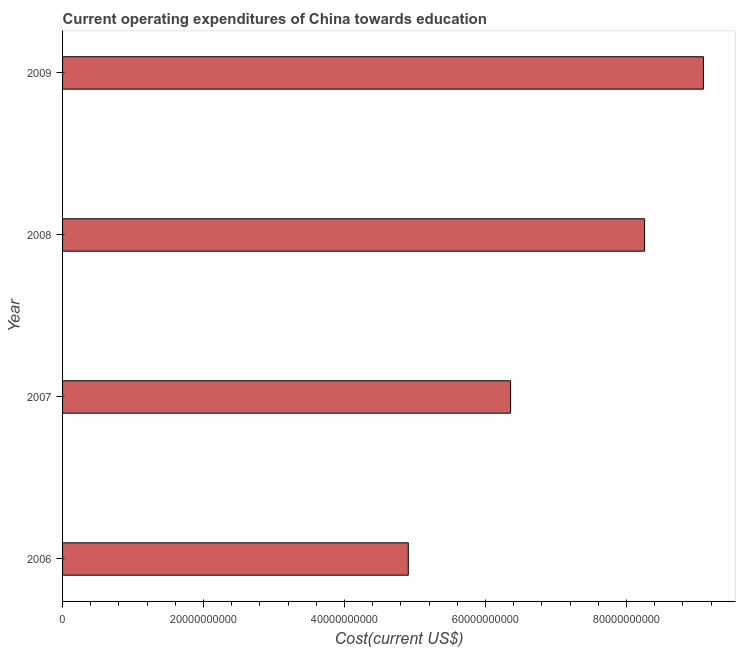Does the graph contain grids?
Ensure brevity in your answer.  No. What is the title of the graph?
Offer a very short reply. Current operating expenditures of China towards education. What is the label or title of the X-axis?
Keep it short and to the point. Cost(current US$). What is the label or title of the Y-axis?
Offer a very short reply. Year. What is the education expenditure in 2009?
Your answer should be compact. 9.09e+1. Across all years, what is the maximum education expenditure?
Make the answer very short. 9.09e+1. Across all years, what is the minimum education expenditure?
Your answer should be very brief. 4.90e+1. In which year was the education expenditure maximum?
Offer a terse response. 2009. What is the sum of the education expenditure?
Keep it short and to the point. 2.86e+11. What is the difference between the education expenditure in 2008 and 2009?
Provide a succinct answer. -8.35e+09. What is the average education expenditure per year?
Your answer should be very brief. 7.15e+1. What is the median education expenditure?
Offer a terse response. 7.31e+1. In how many years, is the education expenditure greater than 60000000000 US$?
Make the answer very short. 3. Do a majority of the years between 2008 and 2009 (inclusive) have education expenditure greater than 40000000000 US$?
Offer a very short reply. Yes. What is the ratio of the education expenditure in 2006 to that in 2009?
Provide a succinct answer. 0.54. What is the difference between the highest and the second highest education expenditure?
Your answer should be very brief. 8.35e+09. What is the difference between the highest and the lowest education expenditure?
Your answer should be compact. 4.19e+1. How many bars are there?
Ensure brevity in your answer.  4. Are all the bars in the graph horizontal?
Make the answer very short. Yes. How many years are there in the graph?
Your answer should be compact. 4. Are the values on the major ticks of X-axis written in scientific E-notation?
Make the answer very short. No. What is the Cost(current US$) in 2006?
Your answer should be very brief. 4.90e+1. What is the Cost(current US$) in 2007?
Provide a succinct answer. 6.36e+1. What is the Cost(current US$) of 2008?
Your response must be concise. 8.26e+1. What is the Cost(current US$) of 2009?
Offer a very short reply. 9.09e+1. What is the difference between the Cost(current US$) in 2006 and 2007?
Make the answer very short. -1.45e+1. What is the difference between the Cost(current US$) in 2006 and 2008?
Your response must be concise. -3.35e+1. What is the difference between the Cost(current US$) in 2006 and 2009?
Keep it short and to the point. -4.19e+1. What is the difference between the Cost(current US$) in 2007 and 2008?
Offer a terse response. -1.90e+1. What is the difference between the Cost(current US$) in 2007 and 2009?
Make the answer very short. -2.74e+1. What is the difference between the Cost(current US$) in 2008 and 2009?
Provide a short and direct response. -8.35e+09. What is the ratio of the Cost(current US$) in 2006 to that in 2007?
Ensure brevity in your answer.  0.77. What is the ratio of the Cost(current US$) in 2006 to that in 2008?
Give a very brief answer. 0.59. What is the ratio of the Cost(current US$) in 2006 to that in 2009?
Your answer should be very brief. 0.54. What is the ratio of the Cost(current US$) in 2007 to that in 2008?
Give a very brief answer. 0.77. What is the ratio of the Cost(current US$) in 2007 to that in 2009?
Provide a succinct answer. 0.7. What is the ratio of the Cost(current US$) in 2008 to that in 2009?
Your response must be concise. 0.91. 